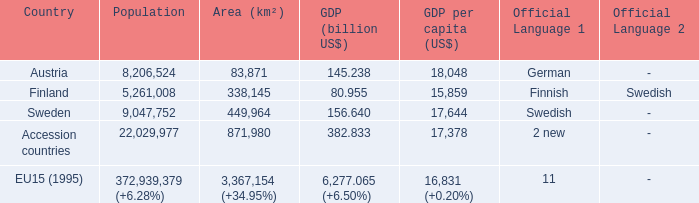Name the member countries for finnish swedish Finland. 